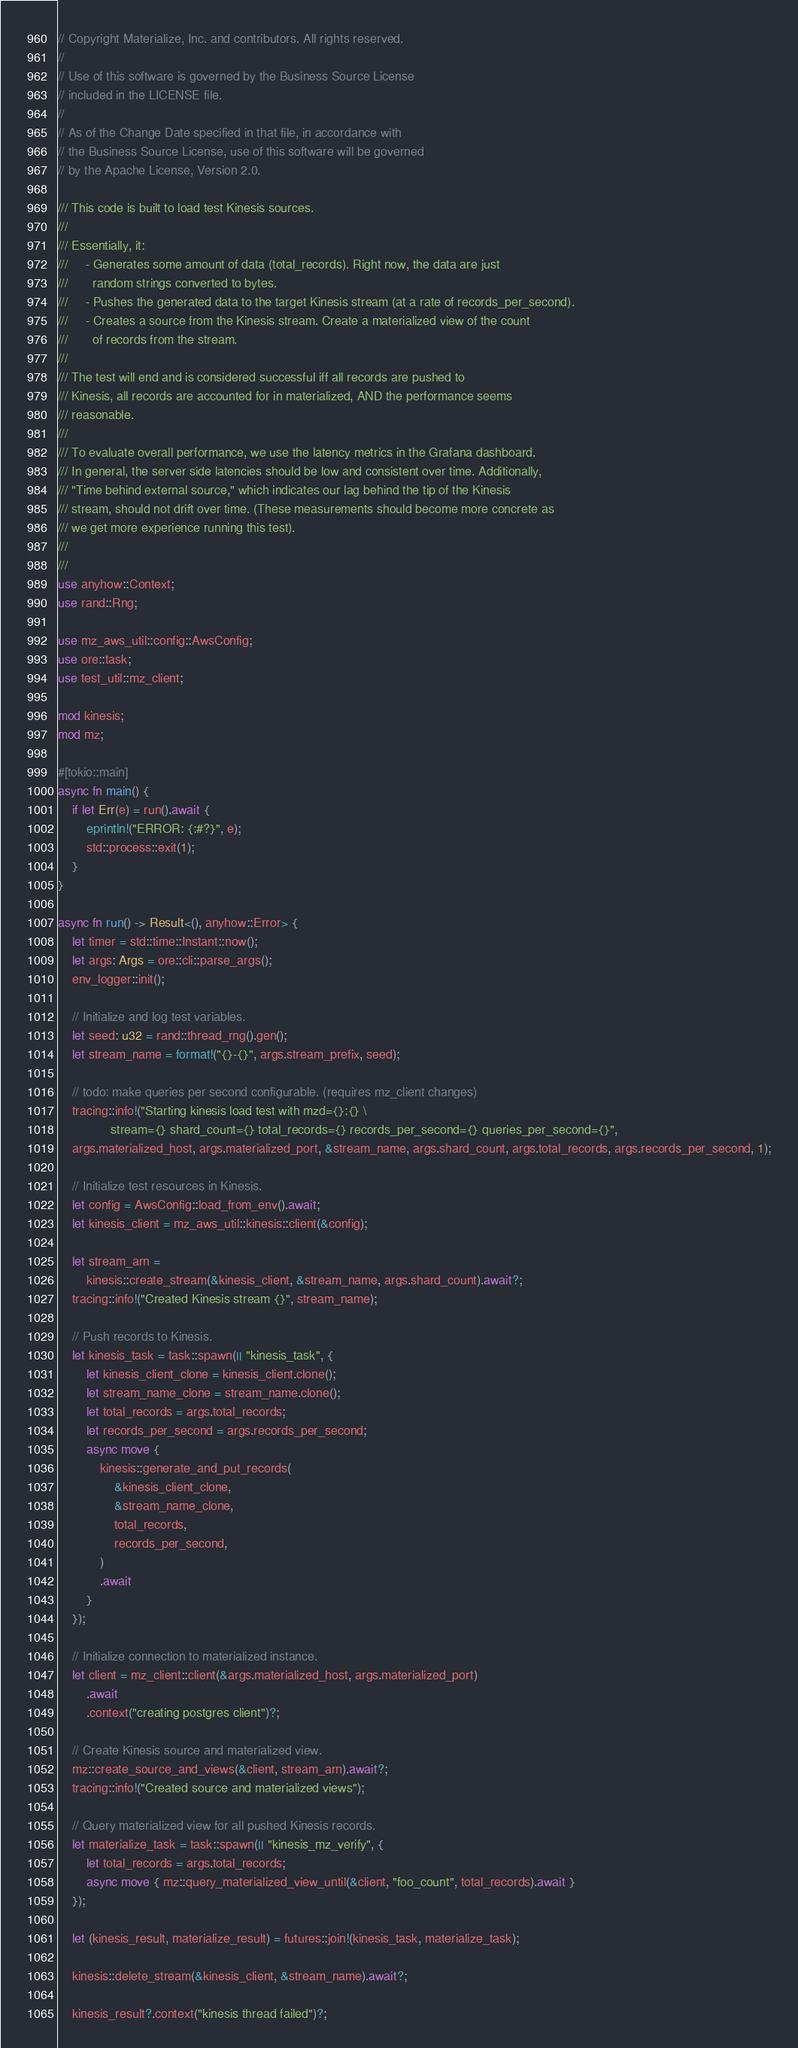<code> <loc_0><loc_0><loc_500><loc_500><_Rust_>// Copyright Materialize, Inc. and contributors. All rights reserved.
//
// Use of this software is governed by the Business Source License
// included in the LICENSE file.
//
// As of the Change Date specified in that file, in accordance with
// the Business Source License, use of this software will be governed
// by the Apache License, Version 2.0.

/// This code is built to load test Kinesis sources.
///
/// Essentially, it:
///     - Generates some amount of data (total_records). Right now, the data are just
///       random strings converted to bytes.
///     - Pushes the generated data to the target Kinesis stream (at a rate of records_per_second).
///     - Creates a source from the Kinesis stream. Create a materialized view of the count
///       of records from the stream.
///
/// The test will end and is considered successful iff all records are pushed to
/// Kinesis, all records are accounted for in materialized, AND the performance seems
/// reasonable.
///
/// To evaluate overall performance, we use the latency metrics in the Grafana dashboard.
/// In general, the server side latencies should be low and consistent over time. Additionally,
/// "Time behind external source," which indicates our lag behind the tip of the Kinesis
/// stream, should not drift over time. (These measurements should become more concrete as
/// we get more experience running this test).
///
///
use anyhow::Context;
use rand::Rng;

use mz_aws_util::config::AwsConfig;
use ore::task;
use test_util::mz_client;

mod kinesis;
mod mz;

#[tokio::main]
async fn main() {
    if let Err(e) = run().await {
        eprintln!("ERROR: {:#?}", e);
        std::process::exit(1);
    }
}

async fn run() -> Result<(), anyhow::Error> {
    let timer = std::time::Instant::now();
    let args: Args = ore::cli::parse_args();
    env_logger::init();

    // Initialize and log test variables.
    let seed: u32 = rand::thread_rng().gen();
    let stream_name = format!("{}-{}", args.stream_prefix, seed);

    // todo: make queries per second configurable. (requires mz_client changes)
    tracing::info!("Starting kinesis load test with mzd={}:{} \
               stream={} shard_count={} total_records={} records_per_second={} queries_per_second={}",
    args.materialized_host, args.materialized_port, &stream_name, args.shard_count, args.total_records, args.records_per_second, 1);

    // Initialize test resources in Kinesis.
    let config = AwsConfig::load_from_env().await;
    let kinesis_client = mz_aws_util::kinesis::client(&config);

    let stream_arn =
        kinesis::create_stream(&kinesis_client, &stream_name, args.shard_count).await?;
    tracing::info!("Created Kinesis stream {}", stream_name);

    // Push records to Kinesis.
    let kinesis_task = task::spawn(|| "kinesis_task", {
        let kinesis_client_clone = kinesis_client.clone();
        let stream_name_clone = stream_name.clone();
        let total_records = args.total_records;
        let records_per_second = args.records_per_second;
        async move {
            kinesis::generate_and_put_records(
                &kinesis_client_clone,
                &stream_name_clone,
                total_records,
                records_per_second,
            )
            .await
        }
    });

    // Initialize connection to materialized instance.
    let client = mz_client::client(&args.materialized_host, args.materialized_port)
        .await
        .context("creating postgres client")?;

    // Create Kinesis source and materialized view.
    mz::create_source_and_views(&client, stream_arn).await?;
    tracing::info!("Created source and materialized views");

    // Query materialized view for all pushed Kinesis records.
    let materialize_task = task::spawn(|| "kinesis_mz_verify", {
        let total_records = args.total_records;
        async move { mz::query_materialized_view_until(&client, "foo_count", total_records).await }
    });

    let (kinesis_result, materialize_result) = futures::join!(kinesis_task, materialize_task);

    kinesis::delete_stream(&kinesis_client, &stream_name).await?;

    kinesis_result?.context("kinesis thread failed")?;</code> 